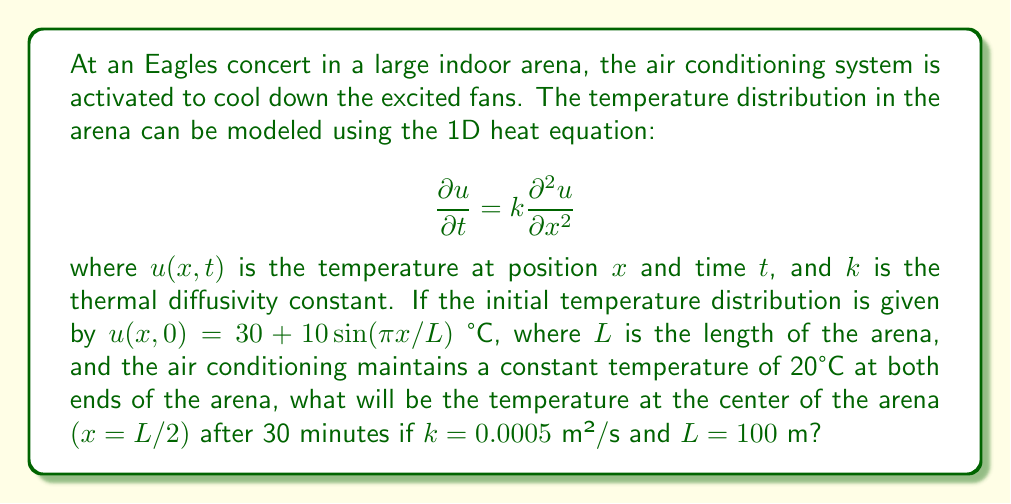Can you answer this question? To solve this problem, we need to use the solution to the 1D heat equation with the given initial and boundary conditions. The solution is given by the Fourier series:

$$u(x,t) = 20 + \sum_{n=1}^{\infty} B_n \sin(\frac{n\pi x}{L}) e^{-k(\frac{n\pi}{L})^2t}$$

where $B_n$ are the Fourier coefficients determined by the initial condition.

Step 1: Determine the Fourier coefficients
For the given initial condition, only $B_1$ is non-zero:
$$B_1 = \frac{2}{L} \int_0^L (30 + 10\sin(\frac{\pi x}{L}) - 20) \sin(\frac{\pi x}{L}) dx = 10$$

Step 2: Simplify the solution
The solution reduces to:
$$u(x,t) = 20 + 10 \sin(\frac{\pi x}{L}) e^{-k(\frac{\pi}{L})^2t}$$

Step 3: Calculate the temperature at the center after 30 minutes
At $x = L/2$ and $t = 30 \times 60 = 1800$ seconds:
$$u(L/2, 1800) = 20 + 10 \sin(\frac{\pi}{2}) e^{-0.0005(\frac{\pi}{100})^2 \times 1800}$$

Step 4: Evaluate the expression
$$u(L/2, 1800) = 20 + 10 \times 1 \times e^{-0.0005(\frac{\pi}{100})^2 \times 1800}$$
$$= 20 + 10 \times e^{-0.0028} \approx 29.97 \text{ °C}$$
Answer: 29.97 °C 